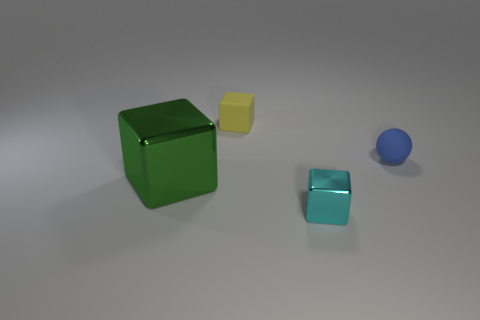Subtract all large green cubes. How many cubes are left? 2 Subtract all green blocks. How many blocks are left? 2 Subtract all spheres. How many objects are left? 3 Subtract 2 blocks. How many blocks are left? 1 Add 2 blocks. How many objects exist? 6 Subtract all cyan balls. Subtract all yellow cylinders. How many balls are left? 1 Subtract all purple blocks. How many purple spheres are left? 0 Subtract all gray rubber balls. Subtract all tiny rubber balls. How many objects are left? 3 Add 3 rubber objects. How many rubber objects are left? 5 Add 1 big yellow cubes. How many big yellow cubes exist? 1 